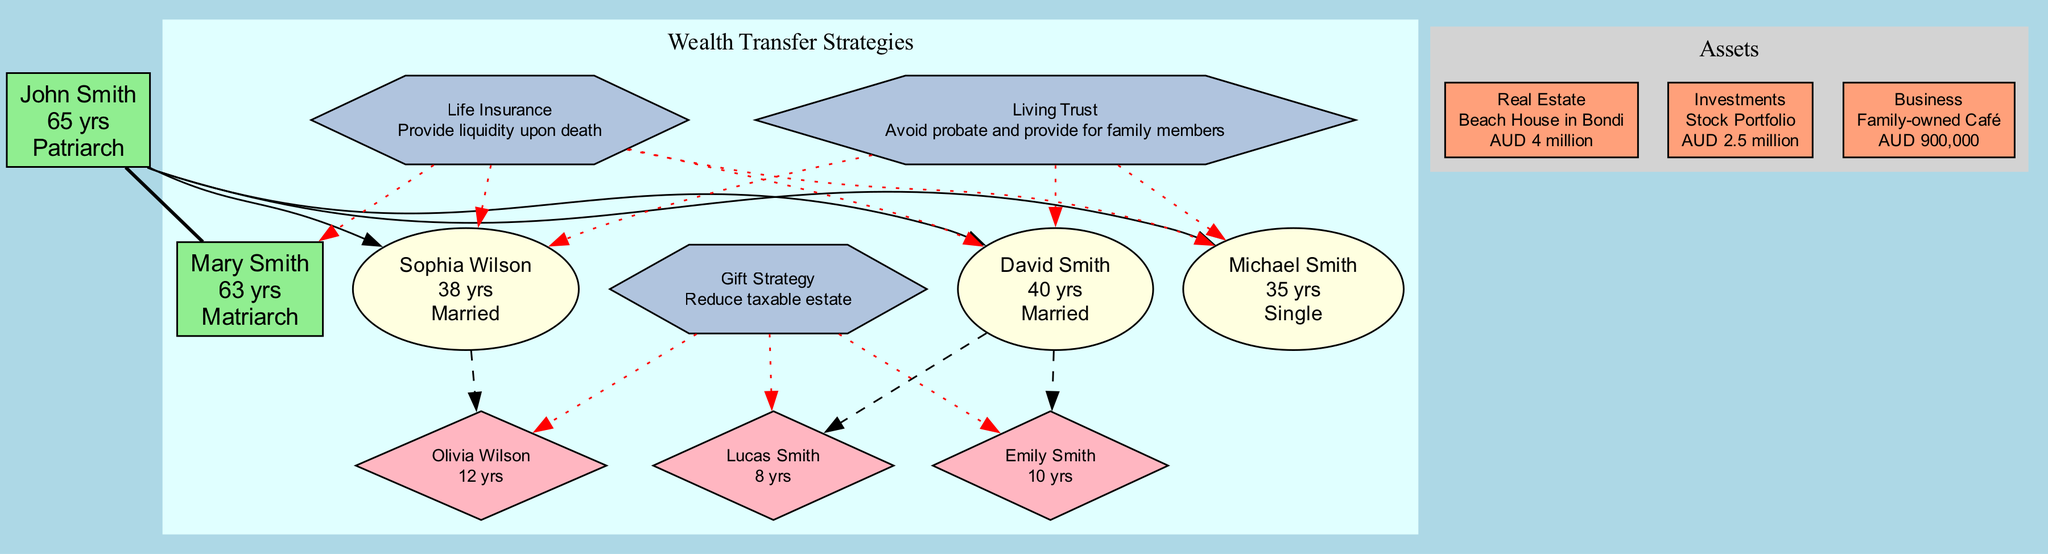What is the value of the Beach House in Bondi? The diagram lists the Beach House as an asset under "Real Estate" with a value of "AUD 4 million."
Answer: AUD 4 million Who is married to Sophia Wilson? The diagram indicates that Sophia Wilson is married, but it does not provide the name of her spouse, representing an unmarked edge from her to an unspecified partner.
Answer: Unknown How many grandchildren does John Smith have? Counting the listed grandchildren in the diagram, John Smith has three: Emily Smith, Lucas Smith, and Olivia Wilson.
Answer: 3 What is the total value of all assets listed? The diagram includes three assets: AUD 4 million for Real Estate, AUD 2.5 million for Investments, and AUD 900,000 for the Business, totaling AUD 7.4 million.
Answer: AUD 7.4 million Which strategy has beneficiaries including Emily Smith? The diagram indicates that the Gift Strategy includes Emily Smith among its beneficiaries, as it specifically lists her as receiving annual gifts.
Answer: Gift Strategy How many family members are beneficiaries of the Life Insurance policy? The diagram shows four beneficiaries for the Life Insurance policy: Mary Smith, David Smith, Sophia Wilson, and Michael Smith, which sums to four family members.
Answer: 4 Who are the beneficiaries of the Living Trust strategy? The beneficiaries of the Living Trust strategy listed in the diagram are David Smith, Sophia Wilson, and Michael Smith, showing who benefits from this strategy.
Answer: David Smith, Sophia Wilson, Michael Smith Which asset type has the lowest value? Among the listed assets, the Family-owned Café is valued at AUD 900,000, which is less than both the Beach House and the Stock Portfolio; thus, it is the lowest.
Answer: Family-owned Café What is the primary purpose of the Living Trust? The diagram states the purpose of the Living Trust as to avoid probate and provide for family members, indicating its intended use in wealth transfer.
Answer: Avoid probate and provide for family members 